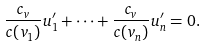Convert formula to latex. <formula><loc_0><loc_0><loc_500><loc_500>\frac { c _ { v } } { c ( v _ { 1 } ) } u ^ { \prime } _ { 1 } + \cdots + \frac { c _ { v } } { c ( v _ { n } ) } u ^ { \prime } _ { n } = 0 .</formula> 